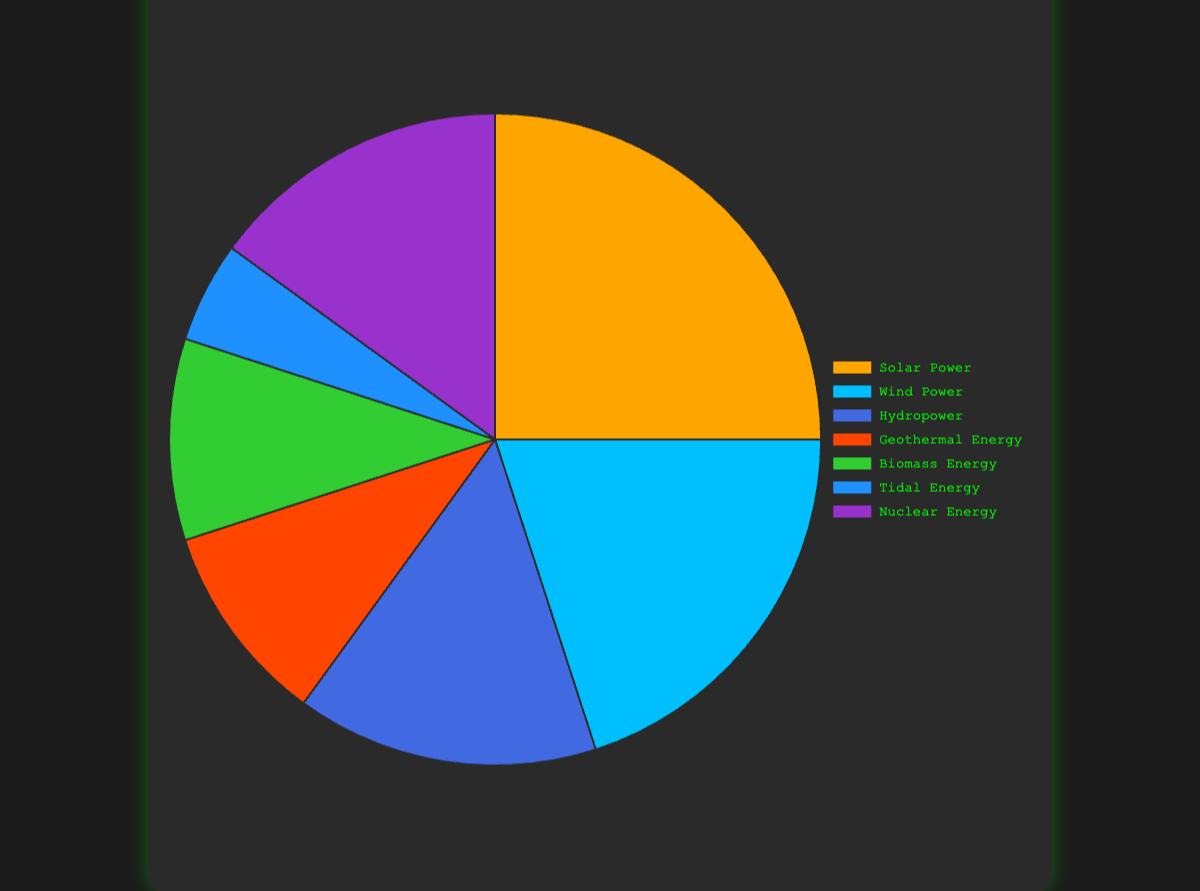What's the most utilized source of renewable energy? To find the most utilized source, we need to look for the slice with the highest percentage in the pie chart. Solar Power is shown as 25%, which is higher than any other source.
Answer: Solar Power How much more is the percentage of Solar Power compared to Tidal Energy? For this, subtract the percentage of Tidal Energy (5%) from the percentage of Solar Power (25%). The difference is 25% - 5% = 20%.
Answer: 20% Which sources of renewable energy are used equally in the mining operations? The pie chart shows that Geothermal Energy and Biomass Energy both have a 10% share, and Hydropower and Nuclear Energy each have a 15% share.
Answer: Geothermal Energy and Biomass Energy; Hydropower and Nuclear Energy What's the average percentage share of all renewable energy sources used in the mining operations? Add all the percentage shares (25 + 20 + 15 + 10 + 10 + 5 + 15 = 100) and divide by the number of sources (7). The average is 100 / 7 ≈ 14.29%.
Answer: 14.29% Which sources combine to cover half of the total renewable energy usage? To find the sources that add up to 50%, start by combining the highest percentages until reaching or exceeding 50%. Solar (25%) + Wind (20%) = 45%, and adding any of the next highest (e.g., Hydropower 15%) exceeds 50%. So, take Solar (25%) + Wind (20%) = 45% and then include any source with the lowest percentage (e.g., Tidal 5%). Therefore, Solar, Wind, and Tidal Energy together cover 25% + 20% + 5% = 50%.
Answer: Solar Power, Wind Power, Tidal Energy Which energy source is represented by the color red in the pie chart? Refer to the color coded in the visual. The chart shows that the segment colored red represents Geothermal Energy
Answer: Geothermal Energy If Tidal Energy's percentage doubled, would it surpass Biomass Energy in terms of usage percentage? The current percentage of Tidal Energy is 5%. If it doubled, it would be 5% * 2 = 10%, which is the same as the percentage of Biomass Energy, not surpassing it.
Answer: No What's the combined percentage of the least used renewable energy sources? The least used sources are Tidal Energy (5%) and both Geothermal Energy and Biomass Energy (10% each). Adding these gives 5% + 10% + 10% = 25%.
Answer: 25% Among the sources contributing exactly 15%, which two renewable energies are they, and what's their combined contribution percentage? The chart shows that Hydropower and Nuclear Energy each contribute 15%. Adding these two gives 15% + 15% = 30%.
Answer: Hydropower, Nuclear Energy; 30% 